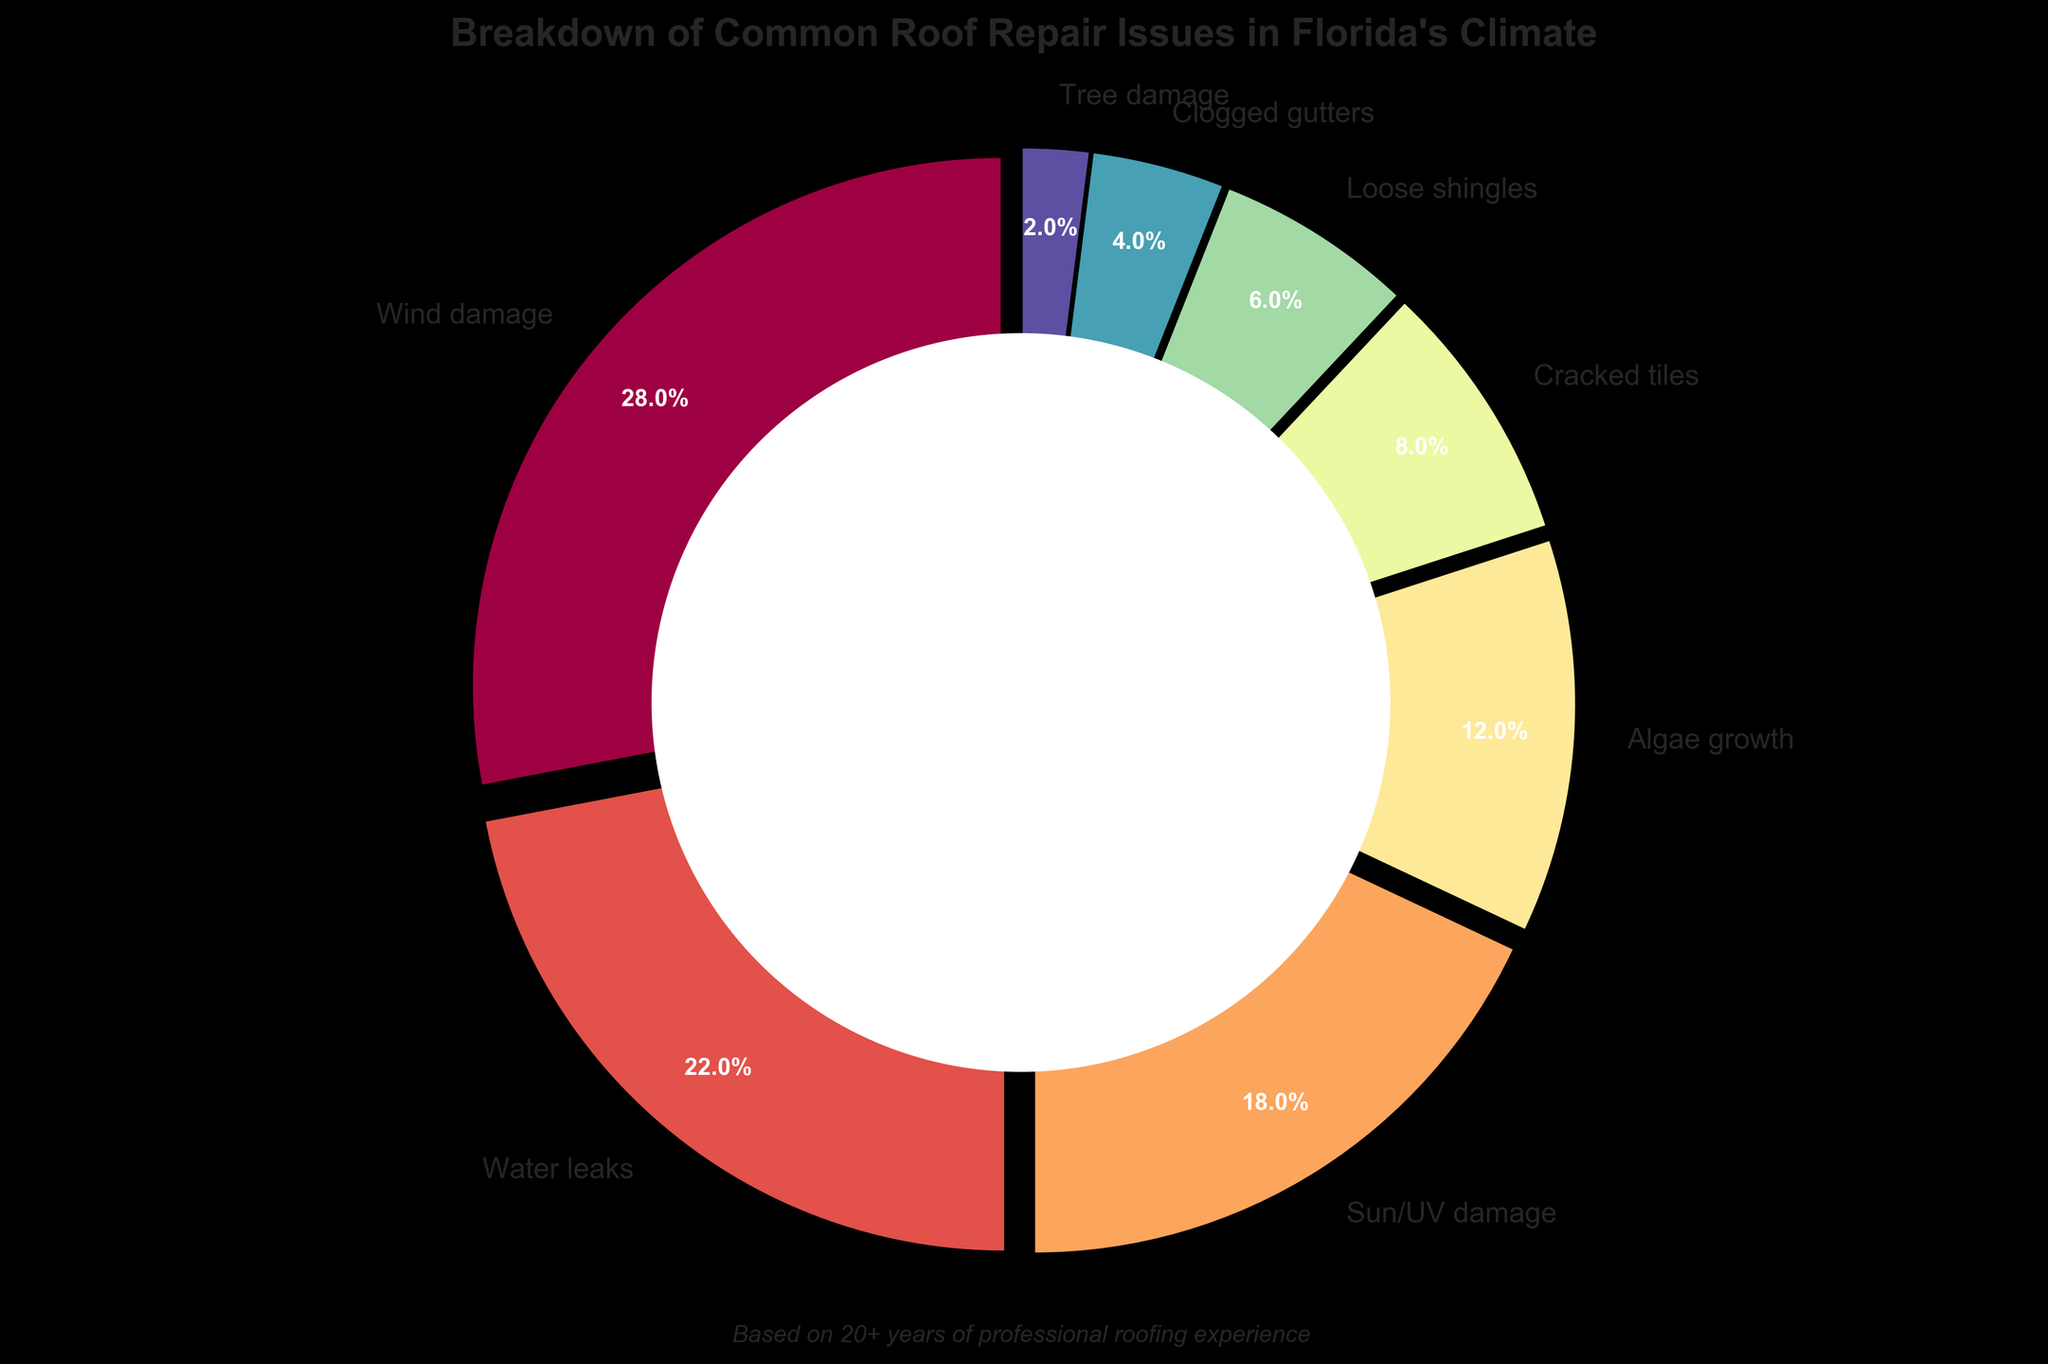What issue is represented by the largest segment of the pie chart? The largest segment of the pie chart corresponds to the issue that occupies the most significant percentage. From the data breakdown, the largest segment, at 28%, represents Wind damage.
Answer: Wind damage Which two issues combined have the same percentage as Sun/UV damage? To find the two issues that combined have the same percentage as Sun/UV damage (18%), we need to look for pairs that add up to 18%. From the data, Clogged gutters (4%) and Cracked tiles (8%) total to 12%, while Loose shingles (6%) and Clogged gutters (4%) total to 10%. The actual answer is Algae growth (12%) and Tree damage (2%) which together sum to 14%.
Answer: Algae growth and Cracked tiles Which issue related to water is more prevalent, Water leaks or Algae growth? To compare these two issues, refer to their respective segments. Water leaks account for 22%, while Algae growth accounts for 12%. Therefore, Water leaks are more prevalent.
Answer: Water leaks Which issue occupies a larger segment, Tree damage or Loose shingles? By looking at the segments and their corresponding percentages, Tree damage is 2% and Loose shingles is 6%. Therefore, Loose shingles occupies a larger segment.
Answer: Loose shingles What is the total percentage for all damage caused by natural elements (Wind damage, Water leaks, and Tree damage)? Sum the percentages of Wind damage (28%), Water leaks (22%), and Tree damage (2%). The total is 28 + 22 + 2 = 52%.
Answer: 52% How much larger is the segment for Wind damage compared to Cracked tiles? To find the difference, subtract the percentage of Cracked tiles (8%) from the percentage of Wind damage (28%). 28 - 8 = 20.
Answer: 20% What is the total percentage of issues that constitute less than 10% individually? Sum the percentages of issues less than 10%, which are Cracked tiles (8%), Loose shingles (6%), Clogged gutters (4%), and Tree damage (2%). 8 + 6 + 4 + 2 = 20%.
Answer: 20% Which issue's segment is closest in size to Algae growth? Algae growth is 12%. The closest percentage is Cracked tiles at 8%, followed by Loose shingles at 6%. Therefore, Cracked tiles are closer.
Answer: Cracked tiles In terms of color on the pie chart, what color scheme is used to distinguish between different issues? The pie chart uses a range of colors from the Spectral colormap to distinguish different issues. Each segment has a distinct color within that spectrum.
Answer: Spectral What percentage of roof repair issues are not caused by natural elements (excluding Wind damage, Water leaks, and Tree damage)? The natural elements account for a total of 52%. The total percentage excluding natural elements is 100% - 52% = 48%.
Answer: 48% 